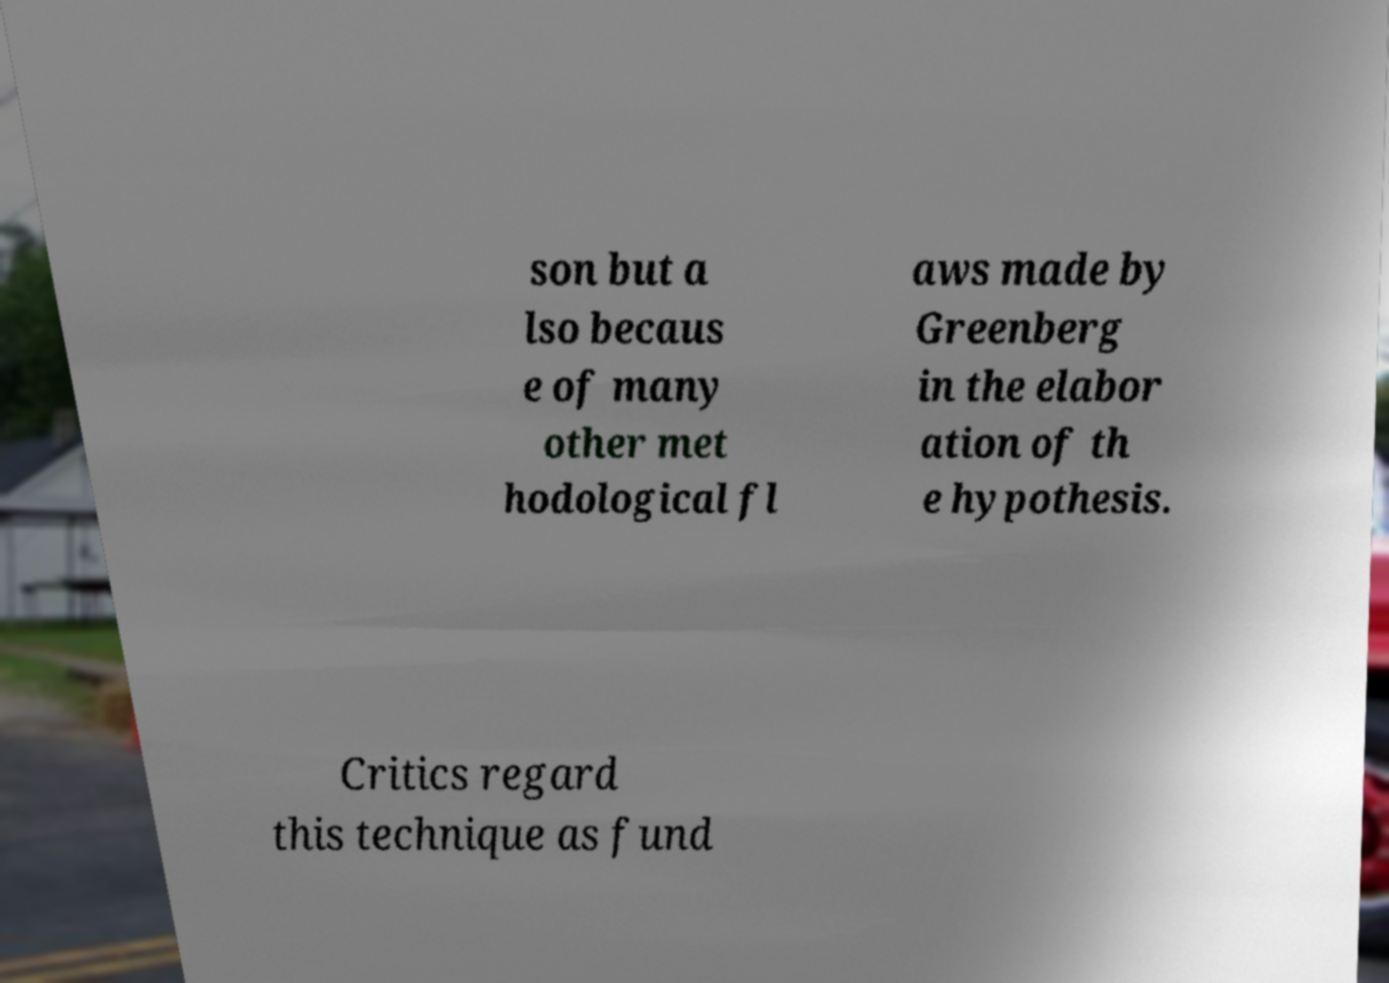There's text embedded in this image that I need extracted. Can you transcribe it verbatim? son but a lso becaus e of many other met hodological fl aws made by Greenberg in the elabor ation of th e hypothesis. Critics regard this technique as fund 